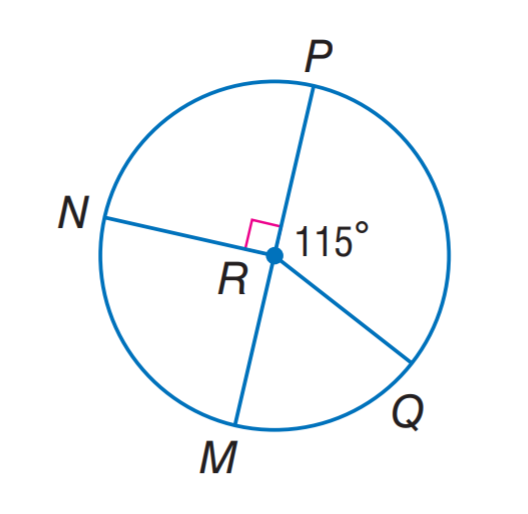Answer the mathemtical geometry problem and directly provide the correct option letter.
Question: P M is a diameter of \odot R. Find m \widehat M N Q.
Choices: A: 115 B: 225 C: 265 D: 295 D 